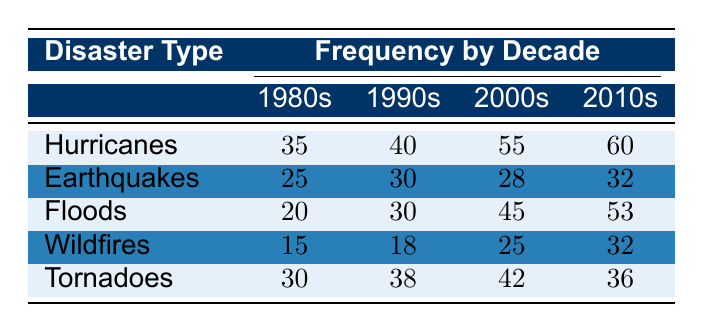What was the frequency of hurricanes in the 1990s? The table shows that the frequency of hurricanes in the 1990s is listed directly under the "1990s" column for hurricanes, which is 40.
Answer: 40 Which type of natural disaster had the highest frequency in the 2010s? To find the highest frequency in the 2010s, we look at the values in that column: Hurricanes (60), Earthquakes (32), Floods (53), Wildfires (32), and Tornadoes (36). The highest value is 60 for hurricanes.
Answer: Hurricanes How many more floods occurred in the 2000s compared to the 1980s? The frequency of floods in the 2000s is 45, and in the 1980s it is 20. The difference is 45 - 20 = 25.
Answer: 25 Did the frequency of wildfires increase or decrease from the 1990s to the 2010s? The frequency of wildfires in the 1990s is 18, and in the 2010s, it is 32. Since 32 is greater than 18, it indicates an increase.
Answer: Increase What is the average frequency of tornadoes over the decades listed? The frequencies for tornadoes are: 30 (1980s), 38 (1990s), 42 (2000s), and 36 (2010s). To find the average, we sum these values: 30 + 38 + 42 + 36 = 146, then divide by the number of decades, which is 4: 146 / 4 = 36.5.
Answer: 36.5 Which natural disaster experienced a decline in frequency from the 1990s to the 2000s? In the 1990s, earthquakes had a frequency of 30, and in the 2000s, it was 28. Since the frequency decreased from 30 to 28, this indicates a decline. No other natural disaster types show this trend.
Answer: Earthquakes How many total hurricanes and floods were recorded in the 2010s? The frequencies for hurricanes and floods in the 2010s are 60 and 53, respectively. To find the total, we sum these values: 60 + 53 = 113.
Answer: 113 Was the frequency of natural disasters in the 1980s higher for hurricanes than for wildfires? The frequency of hurricanes in the 1980s is 35, while for wildfires it is 15. Since 35 is greater than 15, the statement is true.
Answer: Yes What is the highest frequency recorded for any disaster type across all decades? By examining all frequencies from the table, the highest frequency is 60 for hurricanes in the 2010s, as it is the greatest number listed compared to all other entries.
Answer: 60 